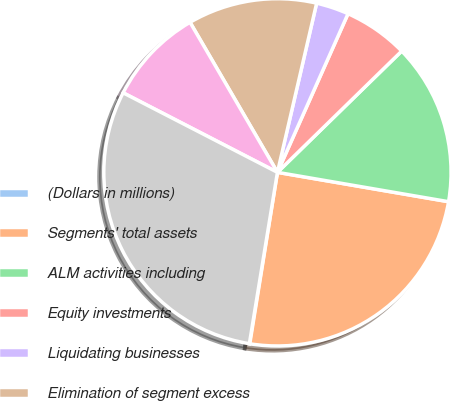<chart> <loc_0><loc_0><loc_500><loc_500><pie_chart><fcel>(Dollars in millions)<fcel>Segments' total assets<fcel>ALM activities including<fcel>Equity investments<fcel>Liquidating businesses<fcel>Elimination of segment excess<fcel>Other<fcel>Consolidated total assets<nl><fcel>0.04%<fcel>24.84%<fcel>15.01%<fcel>6.03%<fcel>3.04%<fcel>12.02%<fcel>9.03%<fcel>29.99%<nl></chart> 